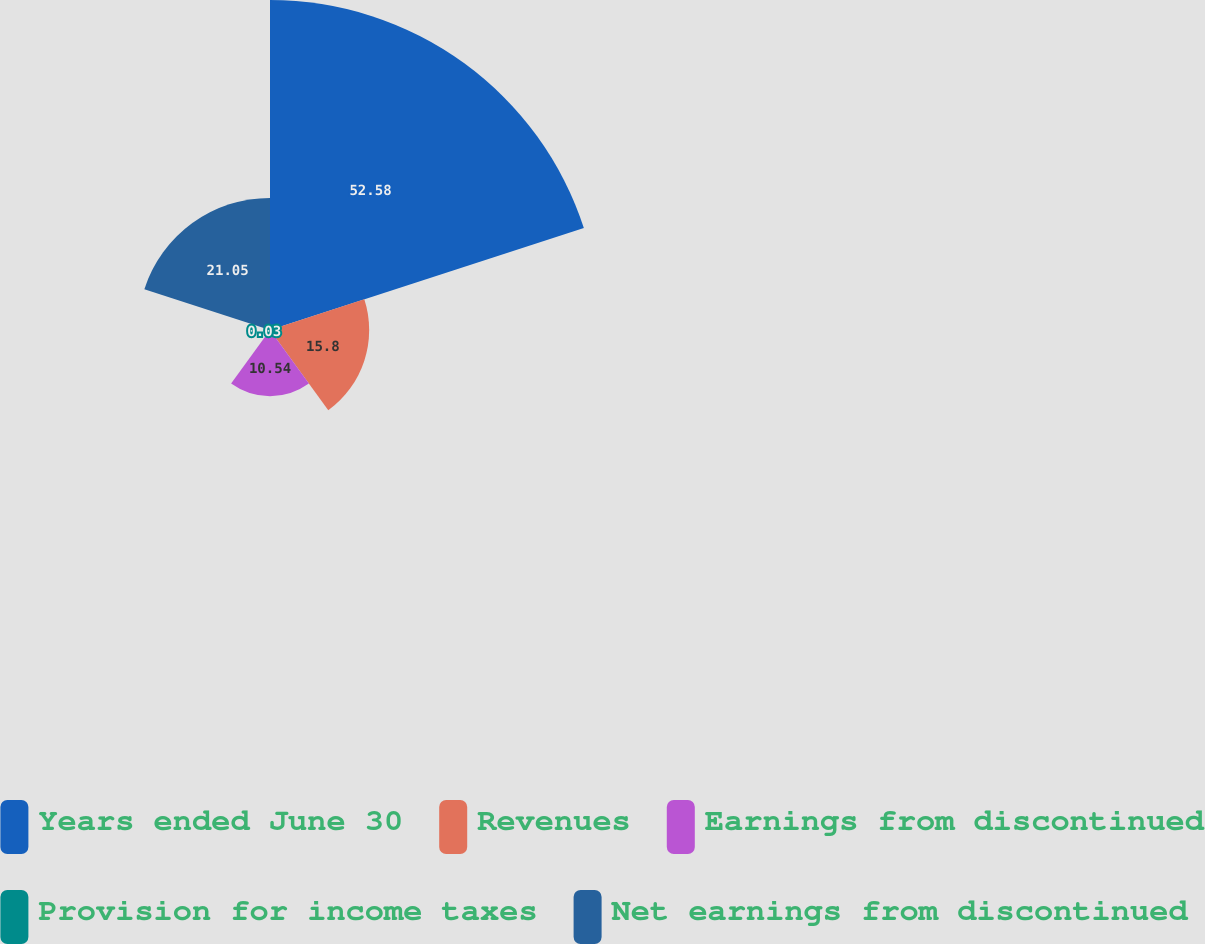<chart> <loc_0><loc_0><loc_500><loc_500><pie_chart><fcel>Years ended June 30<fcel>Revenues<fcel>Earnings from discontinued<fcel>Provision for income taxes<fcel>Net earnings from discontinued<nl><fcel>52.58%<fcel>15.8%<fcel>10.54%<fcel>0.03%<fcel>21.05%<nl></chart> 